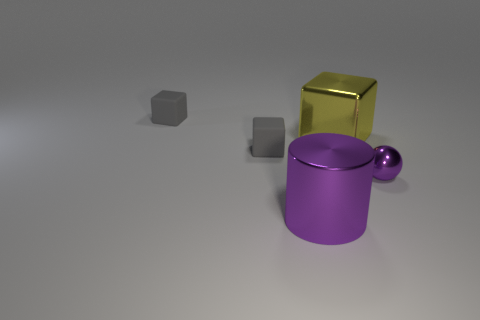How many tiny gray things have the same material as the yellow thing?
Your response must be concise. 0. What is the shape of the metallic object that is the same color as the cylinder?
Your answer should be very brief. Sphere. There is a object right of the yellow shiny thing; does it have the same shape as the big yellow shiny object?
Your response must be concise. No. There is another big object that is the same material as the yellow thing; what is its color?
Make the answer very short. Purple. Are there any large metal cylinders that are behind the tiny gray rubber thing in front of the tiny gray rubber thing behind the yellow metal object?
Your answer should be very brief. No. The tiny shiny object is what shape?
Offer a terse response. Sphere. Are there fewer gray rubber cubes in front of the purple shiny cylinder than big purple metallic cylinders?
Your response must be concise. Yes. Are there any other large purple metallic objects that have the same shape as the large purple object?
Provide a succinct answer. No. What is the shape of the purple metallic object that is the same size as the yellow object?
Give a very brief answer. Cylinder. What number of objects are gray shiny objects or tiny matte things?
Offer a very short reply. 2. 